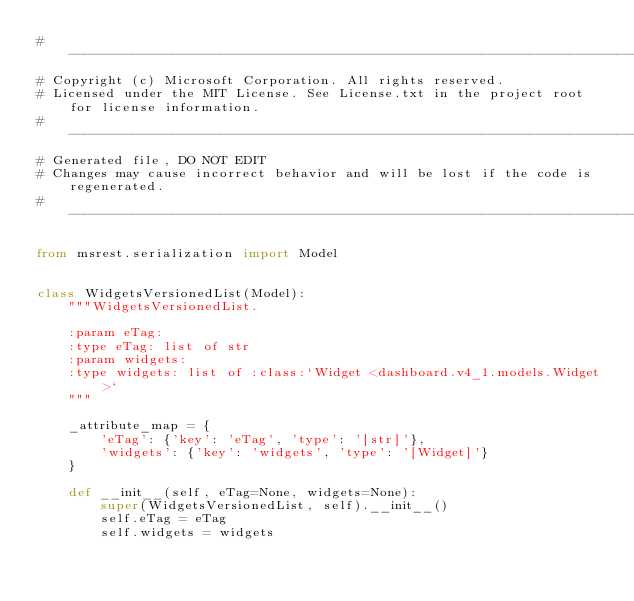Convert code to text. <code><loc_0><loc_0><loc_500><loc_500><_Python_># --------------------------------------------------------------------------------------------
# Copyright (c) Microsoft Corporation. All rights reserved.
# Licensed under the MIT License. See License.txt in the project root for license information.
# --------------------------------------------------------------------------------------------
# Generated file, DO NOT EDIT
# Changes may cause incorrect behavior and will be lost if the code is regenerated.
# --------------------------------------------------------------------------------------------

from msrest.serialization import Model


class WidgetsVersionedList(Model):
    """WidgetsVersionedList.

    :param eTag:
    :type eTag: list of str
    :param widgets:
    :type widgets: list of :class:`Widget <dashboard.v4_1.models.Widget>`
    """

    _attribute_map = {
        'eTag': {'key': 'eTag', 'type': '[str]'},
        'widgets': {'key': 'widgets', 'type': '[Widget]'}
    }

    def __init__(self, eTag=None, widgets=None):
        super(WidgetsVersionedList, self).__init__()
        self.eTag = eTag
        self.widgets = widgets
</code> 